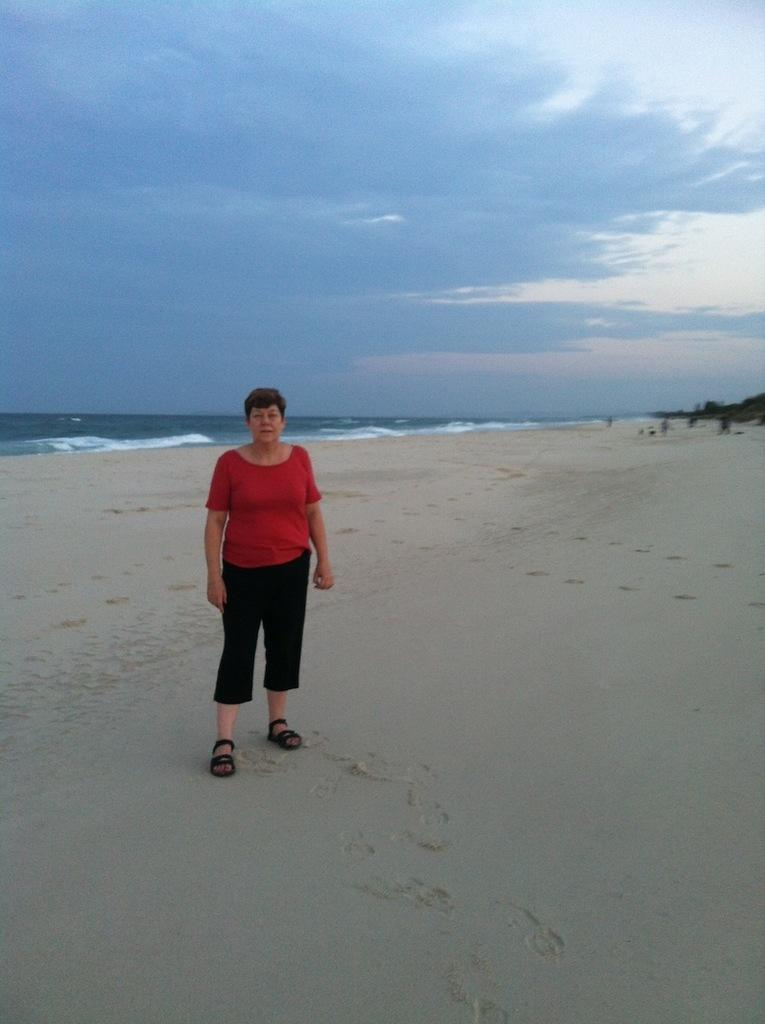What is the main subject of the image? There is a person standing in the image. What can be seen in the background of the image? There is a sea and the sky visible in the background of the image. What type of jelly is being used to decorate the party in the image? There is no jelly or party present in the image; it features a person standing near a sea and the sky. What color is the pencil being used by the person in the image? There is no pencil visible in the image; it only shows a person standing near a sea and the sky. 